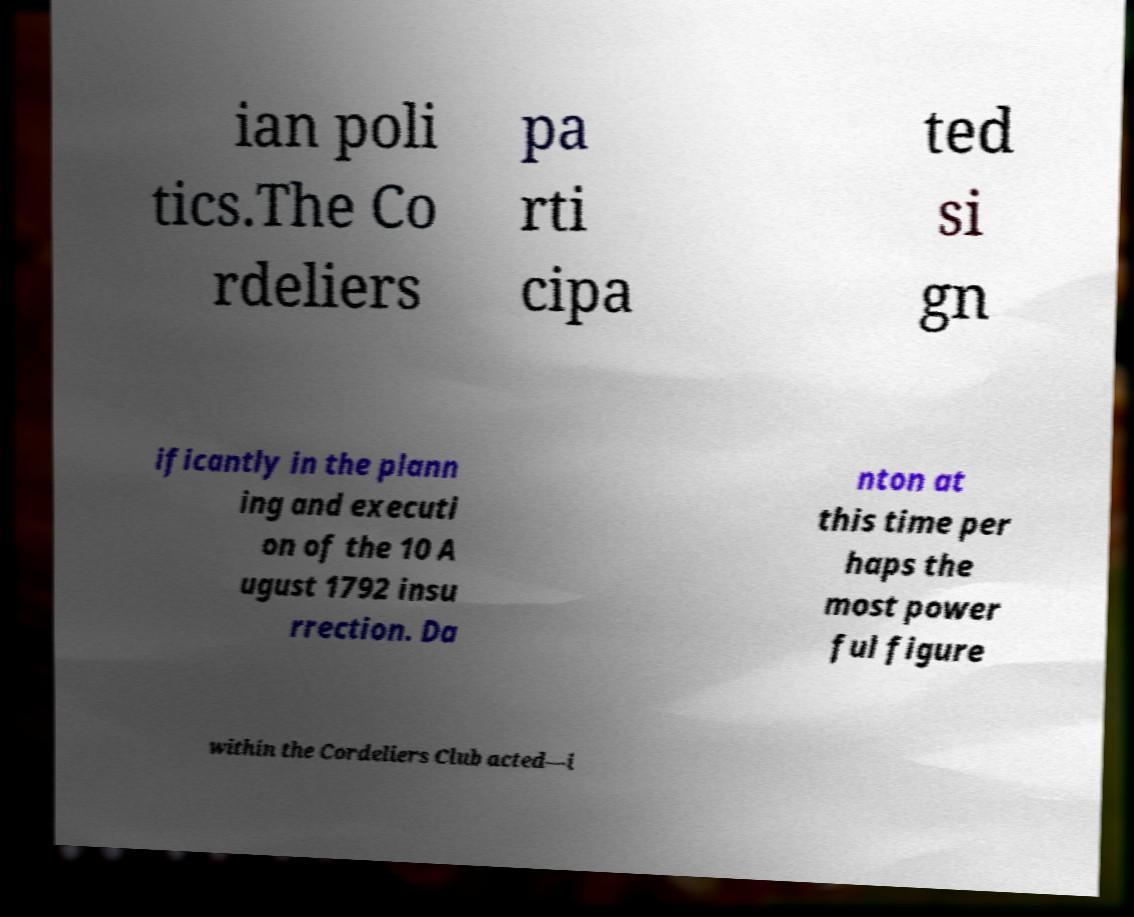Could you extract and type out the text from this image? ian poli tics.The Co rdeliers pa rti cipa ted si gn ificantly in the plann ing and executi on of the 10 A ugust 1792 insu rrection. Da nton at this time per haps the most power ful figure within the Cordeliers Club acted—i 